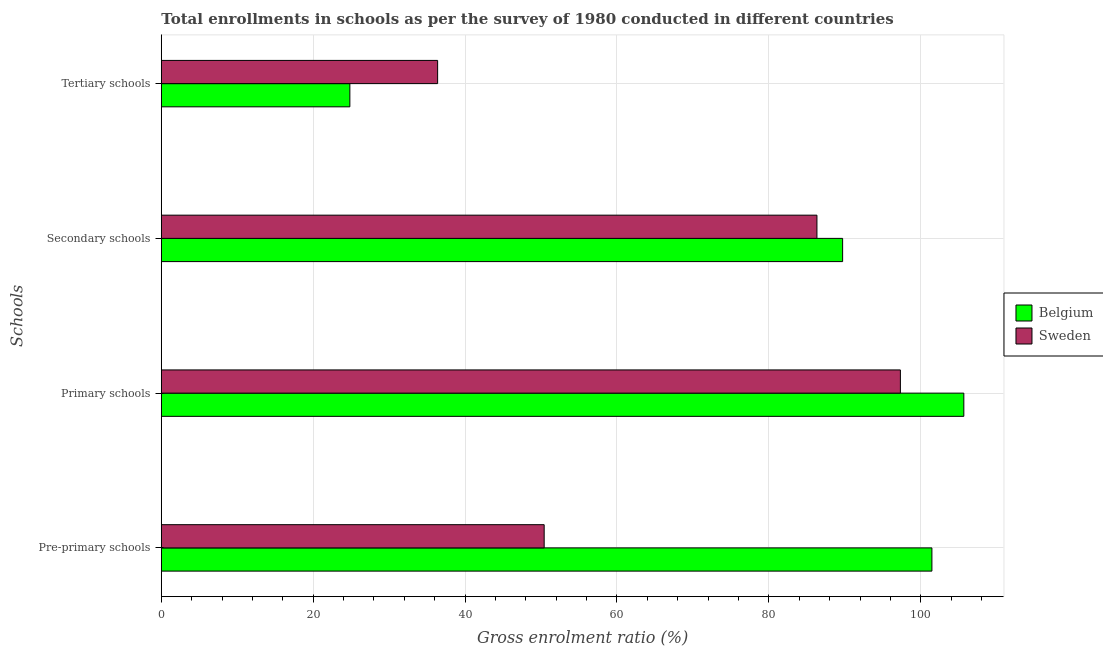How many bars are there on the 3rd tick from the top?
Your answer should be compact. 2. How many bars are there on the 4th tick from the bottom?
Offer a very short reply. 2. What is the label of the 1st group of bars from the top?
Provide a short and direct response. Tertiary schools. What is the gross enrolment ratio in pre-primary schools in Belgium?
Ensure brevity in your answer.  101.47. Across all countries, what is the maximum gross enrolment ratio in pre-primary schools?
Provide a succinct answer. 101.47. Across all countries, what is the minimum gross enrolment ratio in tertiary schools?
Offer a very short reply. 24.83. In which country was the gross enrolment ratio in secondary schools maximum?
Make the answer very short. Belgium. In which country was the gross enrolment ratio in pre-primary schools minimum?
Your answer should be very brief. Sweden. What is the total gross enrolment ratio in tertiary schools in the graph?
Your answer should be very brief. 61.21. What is the difference between the gross enrolment ratio in secondary schools in Belgium and that in Sweden?
Offer a very short reply. 3.38. What is the difference between the gross enrolment ratio in primary schools in Sweden and the gross enrolment ratio in secondary schools in Belgium?
Provide a succinct answer. 7.61. What is the average gross enrolment ratio in pre-primary schools per country?
Offer a very short reply. 75.94. What is the difference between the gross enrolment ratio in pre-primary schools and gross enrolment ratio in tertiary schools in Belgium?
Your response must be concise. 76.64. In how many countries, is the gross enrolment ratio in secondary schools greater than 4 %?
Offer a terse response. 2. What is the ratio of the gross enrolment ratio in primary schools in Sweden to that in Belgium?
Offer a terse response. 0.92. What is the difference between the highest and the second highest gross enrolment ratio in tertiary schools?
Offer a terse response. 11.56. What is the difference between the highest and the lowest gross enrolment ratio in secondary schools?
Provide a short and direct response. 3.38. In how many countries, is the gross enrolment ratio in pre-primary schools greater than the average gross enrolment ratio in pre-primary schools taken over all countries?
Provide a succinct answer. 1. Is it the case that in every country, the sum of the gross enrolment ratio in secondary schools and gross enrolment ratio in pre-primary schools is greater than the sum of gross enrolment ratio in tertiary schools and gross enrolment ratio in primary schools?
Your answer should be very brief. No. What does the 2nd bar from the bottom in Primary schools represents?
Offer a terse response. Sweden. Is it the case that in every country, the sum of the gross enrolment ratio in pre-primary schools and gross enrolment ratio in primary schools is greater than the gross enrolment ratio in secondary schools?
Your answer should be very brief. Yes. How many bars are there?
Ensure brevity in your answer.  8. How many countries are there in the graph?
Make the answer very short. 2. Are the values on the major ticks of X-axis written in scientific E-notation?
Provide a short and direct response. No. Does the graph contain grids?
Your answer should be compact. Yes. Where does the legend appear in the graph?
Your answer should be compact. Center right. How many legend labels are there?
Your answer should be compact. 2. What is the title of the graph?
Your answer should be compact. Total enrollments in schools as per the survey of 1980 conducted in different countries. What is the label or title of the Y-axis?
Your answer should be very brief. Schools. What is the Gross enrolment ratio (%) of Belgium in Pre-primary schools?
Make the answer very short. 101.47. What is the Gross enrolment ratio (%) of Sweden in Pre-primary schools?
Ensure brevity in your answer.  50.41. What is the Gross enrolment ratio (%) in Belgium in Primary schools?
Your answer should be compact. 105.67. What is the Gross enrolment ratio (%) of Sweden in Primary schools?
Offer a very short reply. 97.32. What is the Gross enrolment ratio (%) in Belgium in Secondary schools?
Make the answer very short. 89.71. What is the Gross enrolment ratio (%) in Sweden in Secondary schools?
Make the answer very short. 86.33. What is the Gross enrolment ratio (%) in Belgium in Tertiary schools?
Provide a short and direct response. 24.83. What is the Gross enrolment ratio (%) of Sweden in Tertiary schools?
Make the answer very short. 36.38. Across all Schools, what is the maximum Gross enrolment ratio (%) in Belgium?
Keep it short and to the point. 105.67. Across all Schools, what is the maximum Gross enrolment ratio (%) of Sweden?
Offer a very short reply. 97.32. Across all Schools, what is the minimum Gross enrolment ratio (%) of Belgium?
Provide a succinct answer. 24.83. Across all Schools, what is the minimum Gross enrolment ratio (%) of Sweden?
Provide a short and direct response. 36.38. What is the total Gross enrolment ratio (%) in Belgium in the graph?
Provide a succinct answer. 321.67. What is the total Gross enrolment ratio (%) in Sweden in the graph?
Provide a succinct answer. 270.44. What is the difference between the Gross enrolment ratio (%) in Belgium in Pre-primary schools and that in Primary schools?
Offer a terse response. -4.21. What is the difference between the Gross enrolment ratio (%) in Sweden in Pre-primary schools and that in Primary schools?
Your answer should be compact. -46.91. What is the difference between the Gross enrolment ratio (%) of Belgium in Pre-primary schools and that in Secondary schools?
Offer a terse response. 11.76. What is the difference between the Gross enrolment ratio (%) of Sweden in Pre-primary schools and that in Secondary schools?
Give a very brief answer. -35.92. What is the difference between the Gross enrolment ratio (%) in Belgium in Pre-primary schools and that in Tertiary schools?
Your answer should be very brief. 76.64. What is the difference between the Gross enrolment ratio (%) of Sweden in Pre-primary schools and that in Tertiary schools?
Provide a succinct answer. 14.03. What is the difference between the Gross enrolment ratio (%) in Belgium in Primary schools and that in Secondary schools?
Make the answer very short. 15.96. What is the difference between the Gross enrolment ratio (%) in Sweden in Primary schools and that in Secondary schools?
Your answer should be very brief. 10.99. What is the difference between the Gross enrolment ratio (%) in Belgium in Primary schools and that in Tertiary schools?
Your answer should be compact. 80.85. What is the difference between the Gross enrolment ratio (%) in Sweden in Primary schools and that in Tertiary schools?
Your answer should be compact. 60.94. What is the difference between the Gross enrolment ratio (%) in Belgium in Secondary schools and that in Tertiary schools?
Make the answer very short. 64.89. What is the difference between the Gross enrolment ratio (%) in Sweden in Secondary schools and that in Tertiary schools?
Provide a short and direct response. 49.95. What is the difference between the Gross enrolment ratio (%) of Belgium in Pre-primary schools and the Gross enrolment ratio (%) of Sweden in Primary schools?
Offer a terse response. 4.15. What is the difference between the Gross enrolment ratio (%) in Belgium in Pre-primary schools and the Gross enrolment ratio (%) in Sweden in Secondary schools?
Give a very brief answer. 15.14. What is the difference between the Gross enrolment ratio (%) in Belgium in Pre-primary schools and the Gross enrolment ratio (%) in Sweden in Tertiary schools?
Offer a terse response. 65.08. What is the difference between the Gross enrolment ratio (%) of Belgium in Primary schools and the Gross enrolment ratio (%) of Sweden in Secondary schools?
Give a very brief answer. 19.34. What is the difference between the Gross enrolment ratio (%) of Belgium in Primary schools and the Gross enrolment ratio (%) of Sweden in Tertiary schools?
Offer a terse response. 69.29. What is the difference between the Gross enrolment ratio (%) in Belgium in Secondary schools and the Gross enrolment ratio (%) in Sweden in Tertiary schools?
Offer a very short reply. 53.33. What is the average Gross enrolment ratio (%) in Belgium per Schools?
Give a very brief answer. 80.42. What is the average Gross enrolment ratio (%) in Sweden per Schools?
Your response must be concise. 67.61. What is the difference between the Gross enrolment ratio (%) of Belgium and Gross enrolment ratio (%) of Sweden in Pre-primary schools?
Offer a very short reply. 51.05. What is the difference between the Gross enrolment ratio (%) in Belgium and Gross enrolment ratio (%) in Sweden in Primary schools?
Offer a terse response. 8.35. What is the difference between the Gross enrolment ratio (%) in Belgium and Gross enrolment ratio (%) in Sweden in Secondary schools?
Provide a succinct answer. 3.38. What is the difference between the Gross enrolment ratio (%) of Belgium and Gross enrolment ratio (%) of Sweden in Tertiary schools?
Your response must be concise. -11.56. What is the ratio of the Gross enrolment ratio (%) in Belgium in Pre-primary schools to that in Primary schools?
Offer a terse response. 0.96. What is the ratio of the Gross enrolment ratio (%) of Sweden in Pre-primary schools to that in Primary schools?
Provide a short and direct response. 0.52. What is the ratio of the Gross enrolment ratio (%) in Belgium in Pre-primary schools to that in Secondary schools?
Your answer should be very brief. 1.13. What is the ratio of the Gross enrolment ratio (%) in Sweden in Pre-primary schools to that in Secondary schools?
Offer a very short reply. 0.58. What is the ratio of the Gross enrolment ratio (%) in Belgium in Pre-primary schools to that in Tertiary schools?
Provide a short and direct response. 4.09. What is the ratio of the Gross enrolment ratio (%) in Sweden in Pre-primary schools to that in Tertiary schools?
Ensure brevity in your answer.  1.39. What is the ratio of the Gross enrolment ratio (%) of Belgium in Primary schools to that in Secondary schools?
Make the answer very short. 1.18. What is the ratio of the Gross enrolment ratio (%) of Sweden in Primary schools to that in Secondary schools?
Ensure brevity in your answer.  1.13. What is the ratio of the Gross enrolment ratio (%) of Belgium in Primary schools to that in Tertiary schools?
Provide a succinct answer. 4.26. What is the ratio of the Gross enrolment ratio (%) of Sweden in Primary schools to that in Tertiary schools?
Provide a short and direct response. 2.67. What is the ratio of the Gross enrolment ratio (%) of Belgium in Secondary schools to that in Tertiary schools?
Make the answer very short. 3.61. What is the ratio of the Gross enrolment ratio (%) in Sweden in Secondary schools to that in Tertiary schools?
Keep it short and to the point. 2.37. What is the difference between the highest and the second highest Gross enrolment ratio (%) of Belgium?
Make the answer very short. 4.21. What is the difference between the highest and the second highest Gross enrolment ratio (%) of Sweden?
Give a very brief answer. 10.99. What is the difference between the highest and the lowest Gross enrolment ratio (%) in Belgium?
Offer a very short reply. 80.85. What is the difference between the highest and the lowest Gross enrolment ratio (%) in Sweden?
Provide a short and direct response. 60.94. 